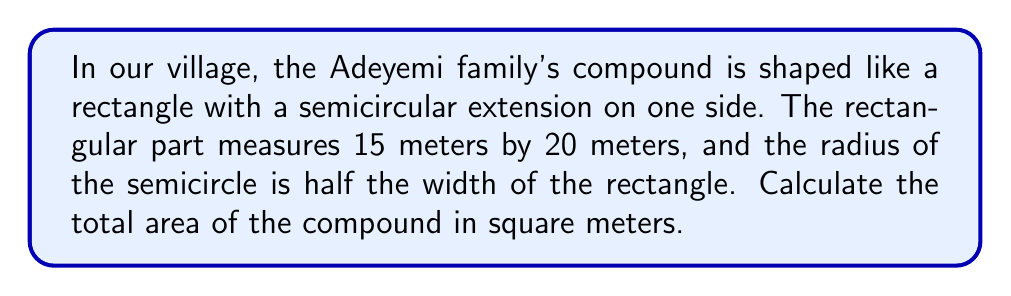Show me your answer to this math problem. Let's approach this step-by-step:

1) First, we need to calculate the area of the rectangular part:
   $$A_{rectangle} = length \times width = 15 \text{ m} \times 20 \text{ m} = 300 \text{ m}^2$$

2) Now, we need to find the radius of the semicircle:
   The width of the rectangle is 20 m, and the radius is half of this.
   $$r = \frac{20 \text{ m}}{2} = 10 \text{ m}$$

3) The area of a full circle is $\pi r^2$, so the area of a semicircle is half of this:
   $$A_{semicircle} = \frac{1}{2} \pi r^2 = \frac{1}{2} \times \pi \times (10 \text{ m})^2 = 50\pi \text{ m}^2$$

4) The total area is the sum of the rectangular area and the semicircular area:
   $$A_{total} = A_{rectangle} + A_{semicircle} = 300 \text{ m}^2 + 50\pi \text{ m}^2$$

5) Simplifying:
   $$A_{total} = (300 + 50\pi) \text{ m}^2 \approx 457.08 \text{ m}^2$$

[asy]
unitsize(0.1cm);
fill((0,0)--(20,0)--(20,15)--(0,15)--cycle,gray(0.9));
fill(arc((20,7.5),7.5,90,270)--cycle,gray(0.9));
draw((0,0)--(20,0)--(20,15)--(0,15)--cycle);
draw(arc((20,7.5),7.5,90,270));
label("15 m", (0,7.5), W);
label("20 m", (10,0), S);
label("r = 10 m", (20,7.5), E);
[/asy]
Answer: $(300 + 50\pi) \text{ m}^2 \approx 457.08 \text{ m}^2$ 